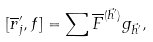<formula> <loc_0><loc_0><loc_500><loc_500>[ \overline { r } ^ { \prime } _ { j } , f ] = \sum \overline { F } ^ { ( \vec { h } ^ { \prime } ) } g _ { \vec { h } ^ { \prime } } ,</formula> 